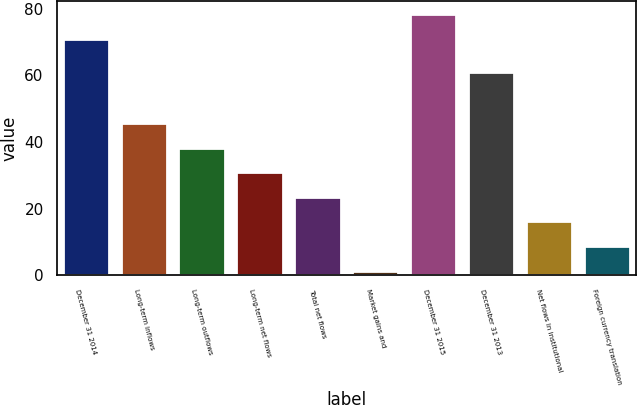Convert chart. <chart><loc_0><loc_0><loc_500><loc_500><bar_chart><fcel>December 31 2014<fcel>Long-term inflows<fcel>Long-term outflows<fcel>Long-term net flows<fcel>Total net flows<fcel>Market gains and<fcel>December 31 2015<fcel>December 31 2013<fcel>Net flows in institutional<fcel>Foreign currency translation<nl><fcel>71.1<fcel>45.76<fcel>38.35<fcel>30.94<fcel>23.53<fcel>1.3<fcel>78.51<fcel>60.9<fcel>16.12<fcel>8.71<nl></chart> 